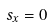<formula> <loc_0><loc_0><loc_500><loc_500>s _ { x } = 0</formula> 